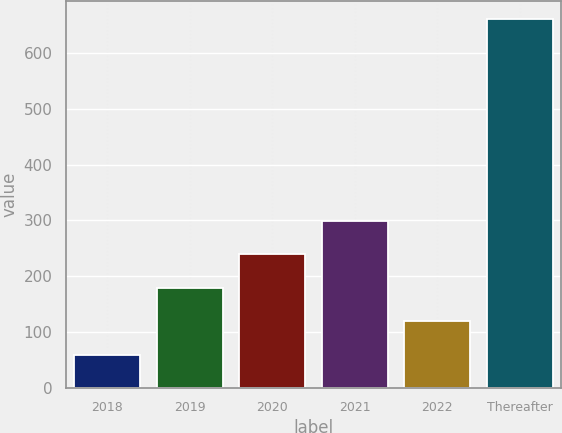Convert chart to OTSL. <chart><loc_0><loc_0><loc_500><loc_500><bar_chart><fcel>2018<fcel>2019<fcel>2020<fcel>2021<fcel>2022<fcel>Thereafter<nl><fcel>59<fcel>179.4<fcel>239.6<fcel>299.8<fcel>119.2<fcel>661<nl></chart> 